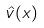Convert formula to latex. <formula><loc_0><loc_0><loc_500><loc_500>\hat { v } ( x )</formula> 